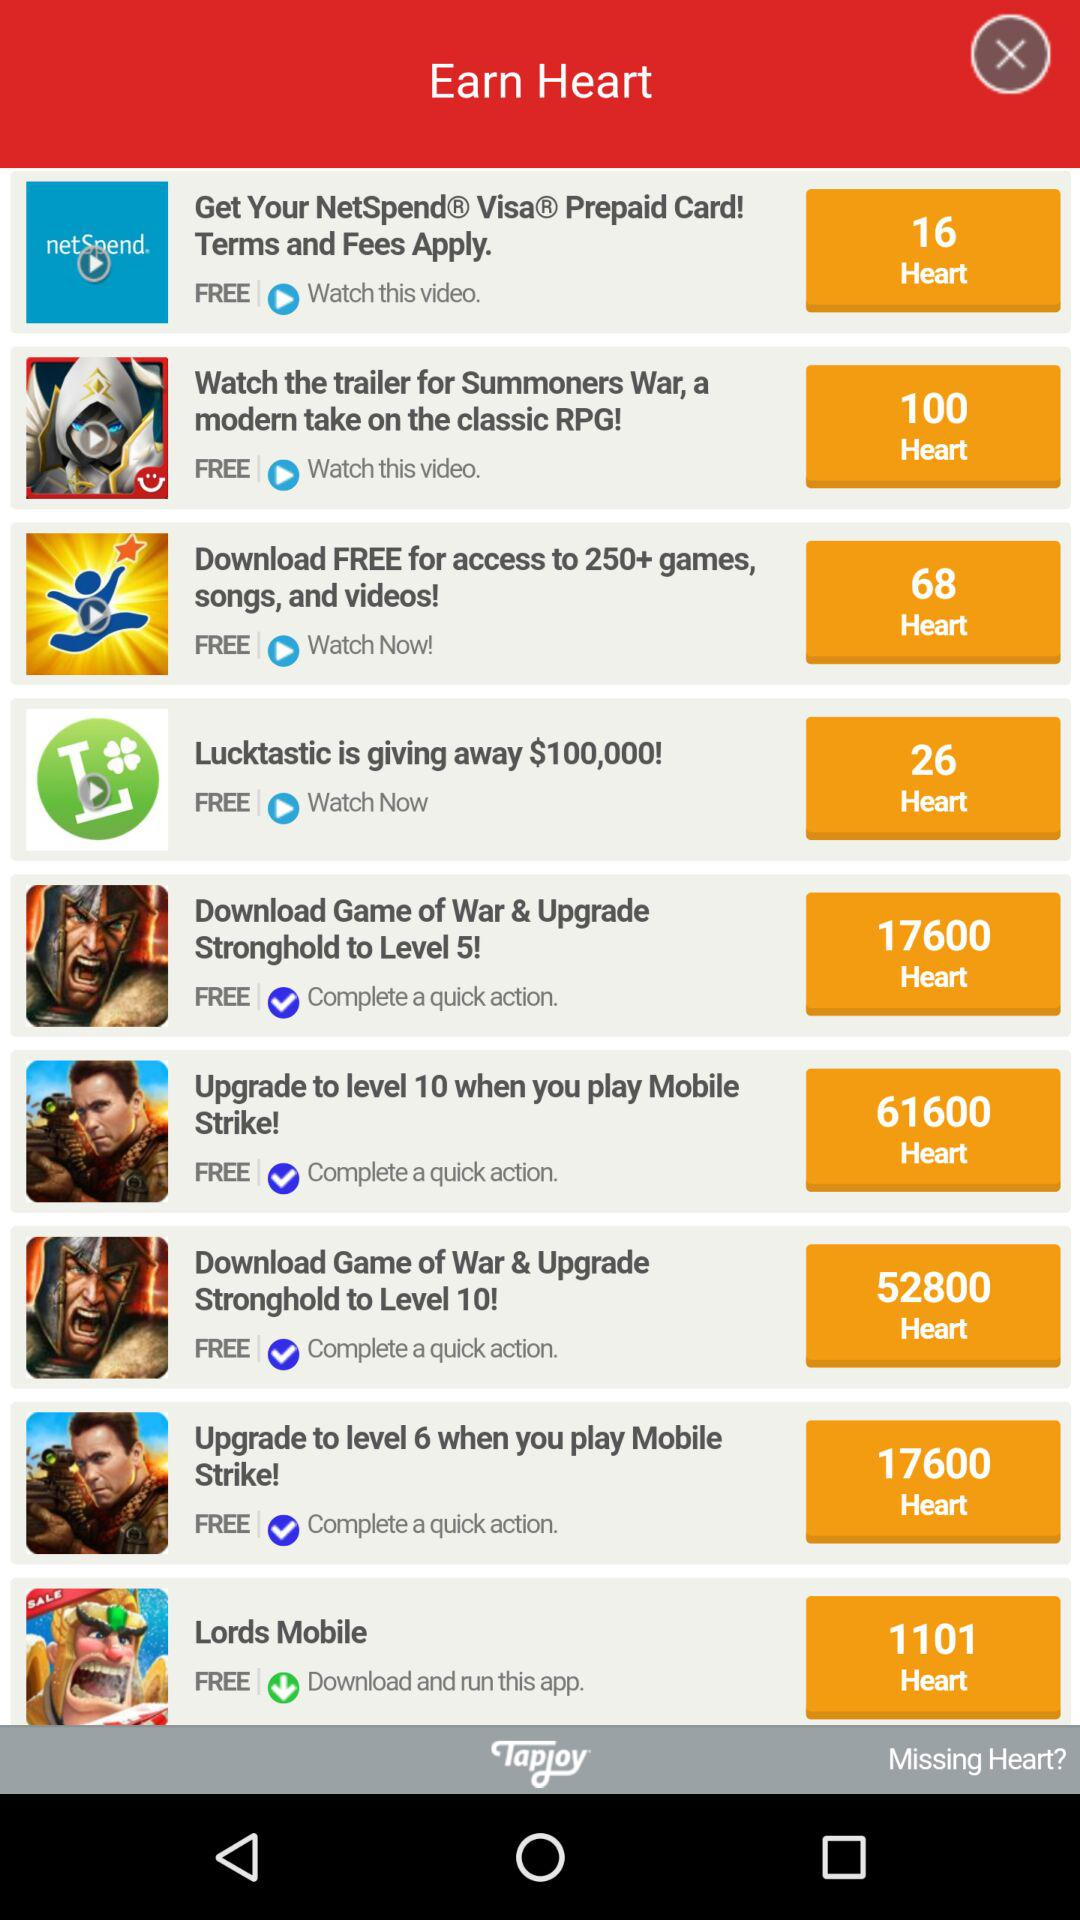How many hearts has "Lords Mobile" earned? "Lords Mobile" has earned 1101 hearts. 